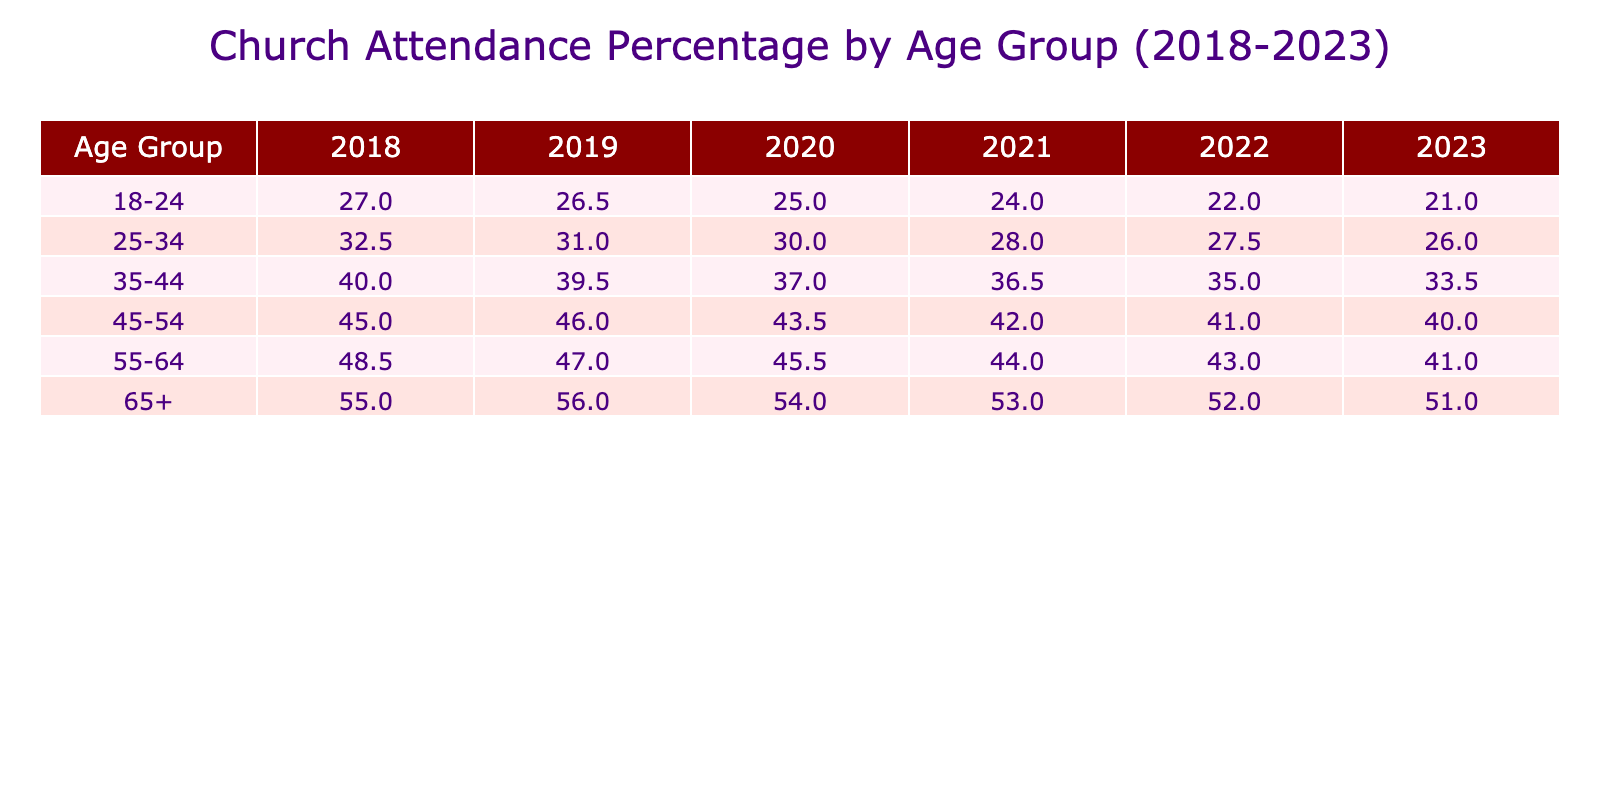What was the church attendance percentage for the age group 35-44 in 2020? In the year 2020, I look at the row for the age group 35-44, and it shows a church attendance percentage of 37.0.
Answer: 37.0 What is the trend in church attendance for the age group 18-24 from 2018 to 2023? To find the trend for the age group 18-24, I check attendance percentages: 27.0 in 2018, 26.5 in 2019, 25.0 in 2020, 24.0 in 2021, 22.0 in 2022, and 21.0 in 2023. The numbers consistently decrease each year, indicating a downward trend.
Answer: Downward trend What was the highest church attendance percentage across all age groups in 2021? I scan through all age groups for the year 2021: 24.0 (18-24), 28.0 (25-34), 36.5 (35-44), 42.0 (45-54), 44.0 (55-64), and 53.0 (65+). The highest percentage is 53.0 for the age group 65+.
Answer: 53.0 What is the average church attendance percentage for the age group 45-54 over the years? For the age group 45-54, I take the percentages for each year: 45.0 (2018), 46.0 (2019), 43.5 (2020), 42.0 (2021), 41.0 (2022), and 40.0 (2023). The total is 45.0 + 46.0 + 43.5 + 42.0 + 41.0 + 40.0 = 258.5. Dividing by the number of years (6), the average is 258.5 / 6 = 43.08.
Answer: 43.08 Is there an increase in church attendance for the age group 55-64 from 2018 to 2023? I look at the percentages for the 55-64 age group over the years: 48.5 in 2018, 47.0 in 2019, 45.5 in 2020, 44.0 in 2021, 43.0 in 2022, and 41.0 in 2023. The values consistently decrease over these years, indicating no increase.
Answer: No 